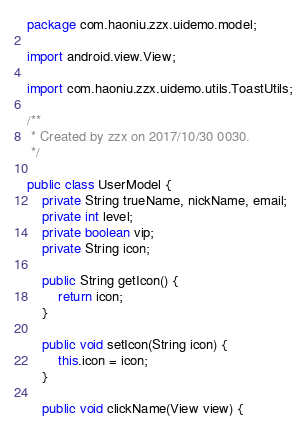Convert code to text. <code><loc_0><loc_0><loc_500><loc_500><_Java_>package com.haoniu.zzx.uidemo.model;

import android.view.View;

import com.haoniu.zzx.uidemo.utils.ToastUtils;

/**
 * Created by zzx on 2017/10/30 0030.
 */

public class UserModel {
    private String trueName, nickName, email;
    private int level;
    private boolean vip;
    private String icon;

    public String getIcon() {
        return icon;
    }

    public void setIcon(String icon) {
        this.icon = icon;
    }

    public void clickName(View view) {</code> 